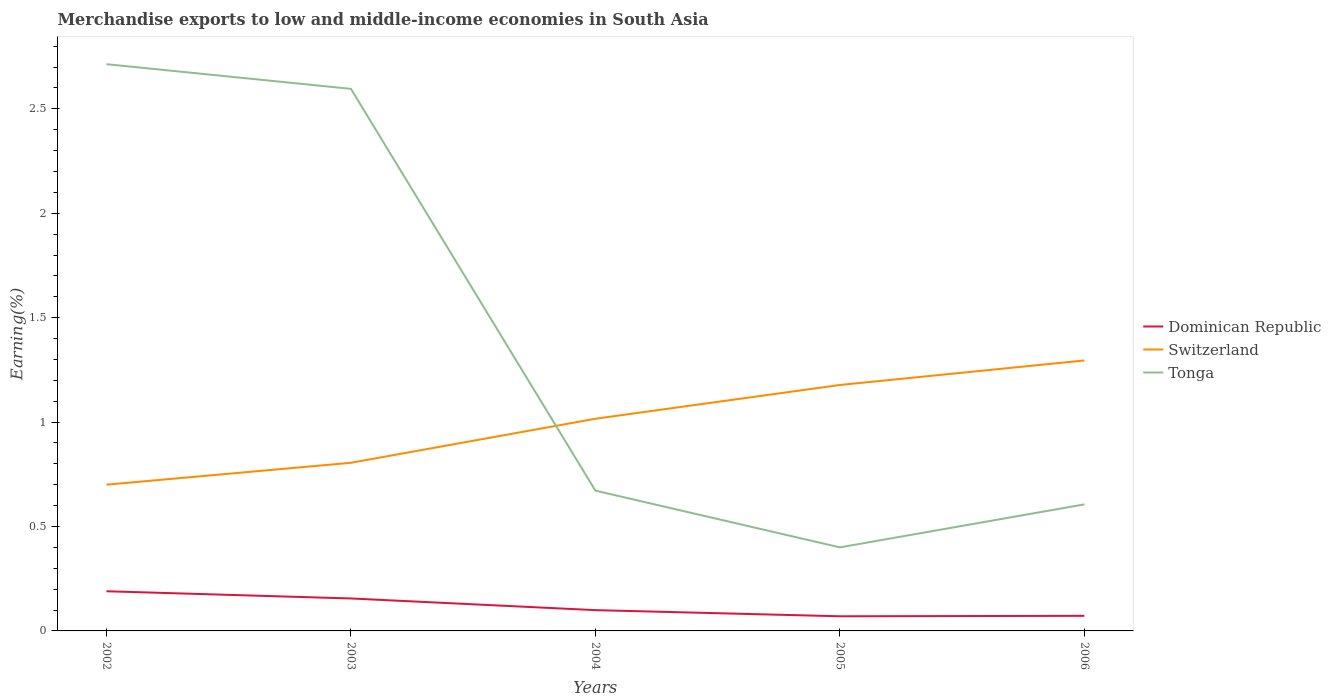Does the line corresponding to Tonga intersect with the line corresponding to Dominican Republic?
Give a very brief answer. No. Is the number of lines equal to the number of legend labels?
Give a very brief answer. Yes. Across all years, what is the maximum percentage of amount earned from merchandise exports in Switzerland?
Your answer should be very brief. 0.7. What is the total percentage of amount earned from merchandise exports in Tonga in the graph?
Your response must be concise. -0.21. What is the difference between the highest and the second highest percentage of amount earned from merchandise exports in Dominican Republic?
Your answer should be compact. 0.12. Is the percentage of amount earned from merchandise exports in Switzerland strictly greater than the percentage of amount earned from merchandise exports in Dominican Republic over the years?
Provide a succinct answer. No. How many lines are there?
Keep it short and to the point. 3. Does the graph contain any zero values?
Provide a succinct answer. No. Where does the legend appear in the graph?
Provide a short and direct response. Center right. How many legend labels are there?
Offer a very short reply. 3. How are the legend labels stacked?
Your answer should be compact. Vertical. What is the title of the graph?
Provide a short and direct response. Merchandise exports to low and middle-income economies in South Asia. Does "Costa Rica" appear as one of the legend labels in the graph?
Your answer should be very brief. No. What is the label or title of the X-axis?
Make the answer very short. Years. What is the label or title of the Y-axis?
Make the answer very short. Earning(%). What is the Earning(%) in Dominican Republic in 2002?
Provide a short and direct response. 0.19. What is the Earning(%) in Switzerland in 2002?
Ensure brevity in your answer.  0.7. What is the Earning(%) in Tonga in 2002?
Provide a succinct answer. 2.71. What is the Earning(%) of Dominican Republic in 2003?
Ensure brevity in your answer.  0.16. What is the Earning(%) in Switzerland in 2003?
Keep it short and to the point. 0.81. What is the Earning(%) of Tonga in 2003?
Keep it short and to the point. 2.6. What is the Earning(%) in Dominican Republic in 2004?
Offer a terse response. 0.1. What is the Earning(%) in Switzerland in 2004?
Your answer should be compact. 1.02. What is the Earning(%) of Tonga in 2004?
Provide a short and direct response. 0.67. What is the Earning(%) in Dominican Republic in 2005?
Offer a very short reply. 0.07. What is the Earning(%) of Switzerland in 2005?
Keep it short and to the point. 1.18. What is the Earning(%) in Tonga in 2005?
Provide a succinct answer. 0.4. What is the Earning(%) of Dominican Republic in 2006?
Your answer should be very brief. 0.07. What is the Earning(%) of Switzerland in 2006?
Your answer should be compact. 1.3. What is the Earning(%) of Tonga in 2006?
Ensure brevity in your answer.  0.61. Across all years, what is the maximum Earning(%) in Dominican Republic?
Offer a very short reply. 0.19. Across all years, what is the maximum Earning(%) of Switzerland?
Give a very brief answer. 1.3. Across all years, what is the maximum Earning(%) of Tonga?
Ensure brevity in your answer.  2.71. Across all years, what is the minimum Earning(%) of Dominican Republic?
Ensure brevity in your answer.  0.07. Across all years, what is the minimum Earning(%) of Switzerland?
Give a very brief answer. 0.7. Across all years, what is the minimum Earning(%) in Tonga?
Provide a short and direct response. 0.4. What is the total Earning(%) in Dominican Republic in the graph?
Offer a terse response. 0.59. What is the total Earning(%) of Switzerland in the graph?
Make the answer very short. 4.99. What is the total Earning(%) of Tonga in the graph?
Provide a short and direct response. 6.99. What is the difference between the Earning(%) in Dominican Republic in 2002 and that in 2003?
Ensure brevity in your answer.  0.03. What is the difference between the Earning(%) of Switzerland in 2002 and that in 2003?
Your answer should be very brief. -0.1. What is the difference between the Earning(%) in Tonga in 2002 and that in 2003?
Your response must be concise. 0.12. What is the difference between the Earning(%) of Dominican Republic in 2002 and that in 2004?
Offer a terse response. 0.09. What is the difference between the Earning(%) in Switzerland in 2002 and that in 2004?
Keep it short and to the point. -0.32. What is the difference between the Earning(%) of Tonga in 2002 and that in 2004?
Provide a succinct answer. 2.04. What is the difference between the Earning(%) of Dominican Republic in 2002 and that in 2005?
Provide a short and direct response. 0.12. What is the difference between the Earning(%) of Switzerland in 2002 and that in 2005?
Your response must be concise. -0.48. What is the difference between the Earning(%) of Tonga in 2002 and that in 2005?
Make the answer very short. 2.31. What is the difference between the Earning(%) of Dominican Republic in 2002 and that in 2006?
Offer a terse response. 0.12. What is the difference between the Earning(%) in Switzerland in 2002 and that in 2006?
Your response must be concise. -0.59. What is the difference between the Earning(%) in Tonga in 2002 and that in 2006?
Provide a short and direct response. 2.11. What is the difference between the Earning(%) of Dominican Republic in 2003 and that in 2004?
Offer a terse response. 0.06. What is the difference between the Earning(%) of Switzerland in 2003 and that in 2004?
Give a very brief answer. -0.21. What is the difference between the Earning(%) in Tonga in 2003 and that in 2004?
Provide a short and direct response. 1.92. What is the difference between the Earning(%) in Dominican Republic in 2003 and that in 2005?
Keep it short and to the point. 0.09. What is the difference between the Earning(%) of Switzerland in 2003 and that in 2005?
Your answer should be very brief. -0.37. What is the difference between the Earning(%) in Tonga in 2003 and that in 2005?
Provide a succinct answer. 2.2. What is the difference between the Earning(%) of Dominican Republic in 2003 and that in 2006?
Offer a very short reply. 0.08. What is the difference between the Earning(%) in Switzerland in 2003 and that in 2006?
Provide a short and direct response. -0.49. What is the difference between the Earning(%) of Tonga in 2003 and that in 2006?
Make the answer very short. 1.99. What is the difference between the Earning(%) in Dominican Republic in 2004 and that in 2005?
Your answer should be very brief. 0.03. What is the difference between the Earning(%) of Switzerland in 2004 and that in 2005?
Offer a terse response. -0.16. What is the difference between the Earning(%) of Tonga in 2004 and that in 2005?
Make the answer very short. 0.27. What is the difference between the Earning(%) of Dominican Republic in 2004 and that in 2006?
Keep it short and to the point. 0.03. What is the difference between the Earning(%) of Switzerland in 2004 and that in 2006?
Make the answer very short. -0.28. What is the difference between the Earning(%) of Tonga in 2004 and that in 2006?
Give a very brief answer. 0.07. What is the difference between the Earning(%) of Dominican Republic in 2005 and that in 2006?
Provide a succinct answer. -0. What is the difference between the Earning(%) of Switzerland in 2005 and that in 2006?
Your answer should be compact. -0.12. What is the difference between the Earning(%) of Tonga in 2005 and that in 2006?
Your answer should be compact. -0.21. What is the difference between the Earning(%) in Dominican Republic in 2002 and the Earning(%) in Switzerland in 2003?
Provide a succinct answer. -0.62. What is the difference between the Earning(%) in Dominican Republic in 2002 and the Earning(%) in Tonga in 2003?
Your answer should be very brief. -2.41. What is the difference between the Earning(%) in Switzerland in 2002 and the Earning(%) in Tonga in 2003?
Ensure brevity in your answer.  -1.9. What is the difference between the Earning(%) of Dominican Republic in 2002 and the Earning(%) of Switzerland in 2004?
Ensure brevity in your answer.  -0.83. What is the difference between the Earning(%) of Dominican Republic in 2002 and the Earning(%) of Tonga in 2004?
Offer a very short reply. -0.48. What is the difference between the Earning(%) in Switzerland in 2002 and the Earning(%) in Tonga in 2004?
Make the answer very short. 0.03. What is the difference between the Earning(%) in Dominican Republic in 2002 and the Earning(%) in Switzerland in 2005?
Your response must be concise. -0.99. What is the difference between the Earning(%) of Dominican Republic in 2002 and the Earning(%) of Tonga in 2005?
Your answer should be very brief. -0.21. What is the difference between the Earning(%) of Switzerland in 2002 and the Earning(%) of Tonga in 2005?
Provide a succinct answer. 0.3. What is the difference between the Earning(%) of Dominican Republic in 2002 and the Earning(%) of Switzerland in 2006?
Offer a very short reply. -1.11. What is the difference between the Earning(%) of Dominican Republic in 2002 and the Earning(%) of Tonga in 2006?
Ensure brevity in your answer.  -0.42. What is the difference between the Earning(%) in Switzerland in 2002 and the Earning(%) in Tonga in 2006?
Provide a short and direct response. 0.09. What is the difference between the Earning(%) of Dominican Republic in 2003 and the Earning(%) of Switzerland in 2004?
Offer a very short reply. -0.86. What is the difference between the Earning(%) of Dominican Republic in 2003 and the Earning(%) of Tonga in 2004?
Make the answer very short. -0.52. What is the difference between the Earning(%) in Switzerland in 2003 and the Earning(%) in Tonga in 2004?
Give a very brief answer. 0.13. What is the difference between the Earning(%) of Dominican Republic in 2003 and the Earning(%) of Switzerland in 2005?
Your answer should be compact. -1.02. What is the difference between the Earning(%) of Dominican Republic in 2003 and the Earning(%) of Tonga in 2005?
Make the answer very short. -0.24. What is the difference between the Earning(%) in Switzerland in 2003 and the Earning(%) in Tonga in 2005?
Your response must be concise. 0.41. What is the difference between the Earning(%) in Dominican Republic in 2003 and the Earning(%) in Switzerland in 2006?
Your answer should be compact. -1.14. What is the difference between the Earning(%) in Dominican Republic in 2003 and the Earning(%) in Tonga in 2006?
Provide a short and direct response. -0.45. What is the difference between the Earning(%) of Switzerland in 2003 and the Earning(%) of Tonga in 2006?
Ensure brevity in your answer.  0.2. What is the difference between the Earning(%) of Dominican Republic in 2004 and the Earning(%) of Switzerland in 2005?
Ensure brevity in your answer.  -1.08. What is the difference between the Earning(%) in Dominican Republic in 2004 and the Earning(%) in Tonga in 2005?
Provide a short and direct response. -0.3. What is the difference between the Earning(%) of Switzerland in 2004 and the Earning(%) of Tonga in 2005?
Your response must be concise. 0.62. What is the difference between the Earning(%) in Dominican Republic in 2004 and the Earning(%) in Switzerland in 2006?
Your answer should be very brief. -1.2. What is the difference between the Earning(%) in Dominican Republic in 2004 and the Earning(%) in Tonga in 2006?
Provide a short and direct response. -0.51. What is the difference between the Earning(%) of Switzerland in 2004 and the Earning(%) of Tonga in 2006?
Make the answer very short. 0.41. What is the difference between the Earning(%) in Dominican Republic in 2005 and the Earning(%) in Switzerland in 2006?
Your answer should be very brief. -1.23. What is the difference between the Earning(%) in Dominican Republic in 2005 and the Earning(%) in Tonga in 2006?
Offer a very short reply. -0.54. What is the difference between the Earning(%) in Switzerland in 2005 and the Earning(%) in Tonga in 2006?
Offer a very short reply. 0.57. What is the average Earning(%) of Dominican Republic per year?
Ensure brevity in your answer.  0.12. What is the average Earning(%) of Switzerland per year?
Provide a succinct answer. 1. What is the average Earning(%) in Tonga per year?
Your response must be concise. 1.4. In the year 2002, what is the difference between the Earning(%) of Dominican Republic and Earning(%) of Switzerland?
Give a very brief answer. -0.51. In the year 2002, what is the difference between the Earning(%) of Dominican Republic and Earning(%) of Tonga?
Offer a terse response. -2.52. In the year 2002, what is the difference between the Earning(%) in Switzerland and Earning(%) in Tonga?
Offer a terse response. -2.01. In the year 2003, what is the difference between the Earning(%) of Dominican Republic and Earning(%) of Switzerland?
Provide a short and direct response. -0.65. In the year 2003, what is the difference between the Earning(%) of Dominican Republic and Earning(%) of Tonga?
Keep it short and to the point. -2.44. In the year 2003, what is the difference between the Earning(%) of Switzerland and Earning(%) of Tonga?
Keep it short and to the point. -1.79. In the year 2004, what is the difference between the Earning(%) of Dominican Republic and Earning(%) of Switzerland?
Provide a succinct answer. -0.92. In the year 2004, what is the difference between the Earning(%) of Dominican Republic and Earning(%) of Tonga?
Give a very brief answer. -0.57. In the year 2004, what is the difference between the Earning(%) in Switzerland and Earning(%) in Tonga?
Provide a short and direct response. 0.34. In the year 2005, what is the difference between the Earning(%) of Dominican Republic and Earning(%) of Switzerland?
Provide a succinct answer. -1.11. In the year 2005, what is the difference between the Earning(%) of Dominican Republic and Earning(%) of Tonga?
Your answer should be compact. -0.33. In the year 2005, what is the difference between the Earning(%) of Switzerland and Earning(%) of Tonga?
Your response must be concise. 0.78. In the year 2006, what is the difference between the Earning(%) in Dominican Republic and Earning(%) in Switzerland?
Your answer should be compact. -1.22. In the year 2006, what is the difference between the Earning(%) of Dominican Republic and Earning(%) of Tonga?
Your response must be concise. -0.53. In the year 2006, what is the difference between the Earning(%) of Switzerland and Earning(%) of Tonga?
Your answer should be very brief. 0.69. What is the ratio of the Earning(%) in Dominican Republic in 2002 to that in 2003?
Your response must be concise. 1.22. What is the ratio of the Earning(%) in Switzerland in 2002 to that in 2003?
Provide a succinct answer. 0.87. What is the ratio of the Earning(%) in Tonga in 2002 to that in 2003?
Keep it short and to the point. 1.05. What is the ratio of the Earning(%) in Dominican Republic in 2002 to that in 2004?
Your response must be concise. 1.91. What is the ratio of the Earning(%) in Switzerland in 2002 to that in 2004?
Your response must be concise. 0.69. What is the ratio of the Earning(%) of Tonga in 2002 to that in 2004?
Provide a short and direct response. 4.04. What is the ratio of the Earning(%) of Dominican Republic in 2002 to that in 2005?
Your response must be concise. 2.71. What is the ratio of the Earning(%) in Switzerland in 2002 to that in 2005?
Make the answer very short. 0.59. What is the ratio of the Earning(%) of Tonga in 2002 to that in 2005?
Offer a terse response. 6.78. What is the ratio of the Earning(%) in Dominican Republic in 2002 to that in 2006?
Provide a short and direct response. 2.63. What is the ratio of the Earning(%) of Switzerland in 2002 to that in 2006?
Your answer should be compact. 0.54. What is the ratio of the Earning(%) of Tonga in 2002 to that in 2006?
Offer a very short reply. 4.48. What is the ratio of the Earning(%) of Dominican Republic in 2003 to that in 2004?
Offer a terse response. 1.56. What is the ratio of the Earning(%) of Switzerland in 2003 to that in 2004?
Your answer should be very brief. 0.79. What is the ratio of the Earning(%) in Tonga in 2003 to that in 2004?
Offer a terse response. 3.86. What is the ratio of the Earning(%) of Dominican Republic in 2003 to that in 2005?
Provide a succinct answer. 2.22. What is the ratio of the Earning(%) in Switzerland in 2003 to that in 2005?
Offer a very short reply. 0.68. What is the ratio of the Earning(%) of Tonga in 2003 to that in 2005?
Provide a short and direct response. 6.49. What is the ratio of the Earning(%) in Dominican Republic in 2003 to that in 2006?
Ensure brevity in your answer.  2.15. What is the ratio of the Earning(%) in Switzerland in 2003 to that in 2006?
Your answer should be very brief. 0.62. What is the ratio of the Earning(%) in Tonga in 2003 to that in 2006?
Your answer should be very brief. 4.28. What is the ratio of the Earning(%) of Dominican Republic in 2004 to that in 2005?
Give a very brief answer. 1.42. What is the ratio of the Earning(%) in Switzerland in 2004 to that in 2005?
Your answer should be very brief. 0.86. What is the ratio of the Earning(%) in Tonga in 2004 to that in 2005?
Offer a terse response. 1.68. What is the ratio of the Earning(%) in Dominican Republic in 2004 to that in 2006?
Ensure brevity in your answer.  1.38. What is the ratio of the Earning(%) in Switzerland in 2004 to that in 2006?
Ensure brevity in your answer.  0.78. What is the ratio of the Earning(%) in Tonga in 2004 to that in 2006?
Make the answer very short. 1.11. What is the ratio of the Earning(%) of Dominican Republic in 2005 to that in 2006?
Provide a succinct answer. 0.97. What is the ratio of the Earning(%) of Switzerland in 2005 to that in 2006?
Give a very brief answer. 0.91. What is the ratio of the Earning(%) in Tonga in 2005 to that in 2006?
Ensure brevity in your answer.  0.66. What is the difference between the highest and the second highest Earning(%) of Dominican Republic?
Make the answer very short. 0.03. What is the difference between the highest and the second highest Earning(%) in Switzerland?
Provide a succinct answer. 0.12. What is the difference between the highest and the second highest Earning(%) of Tonga?
Keep it short and to the point. 0.12. What is the difference between the highest and the lowest Earning(%) of Dominican Republic?
Provide a succinct answer. 0.12. What is the difference between the highest and the lowest Earning(%) in Switzerland?
Keep it short and to the point. 0.59. What is the difference between the highest and the lowest Earning(%) of Tonga?
Provide a succinct answer. 2.31. 